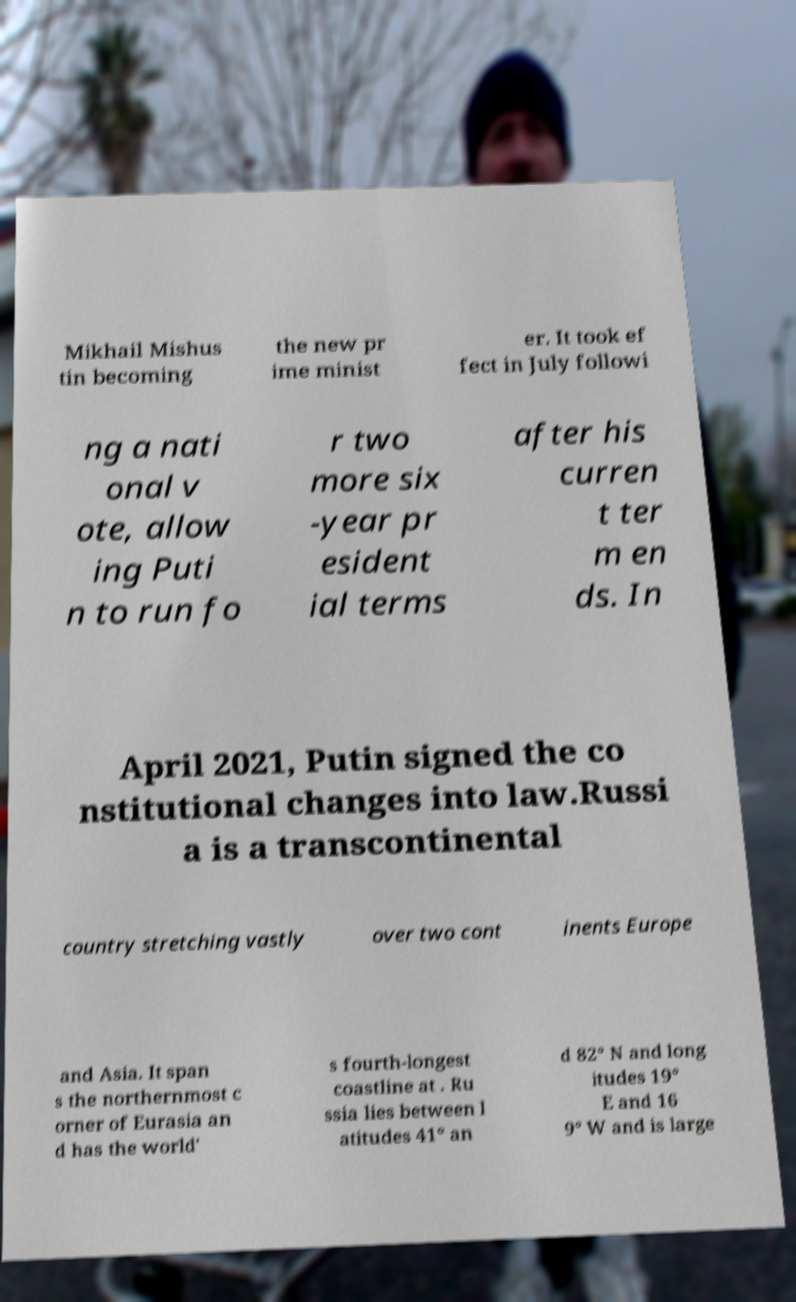Please read and relay the text visible in this image. What does it say? Mikhail Mishus tin becoming the new pr ime minist er. It took ef fect in July followi ng a nati onal v ote, allow ing Puti n to run fo r two more six -year pr esident ial terms after his curren t ter m en ds. In April 2021, Putin signed the co nstitutional changes into law.Russi a is a transcontinental country stretching vastly over two cont inents Europe and Asia. It span s the northernmost c orner of Eurasia an d has the world' s fourth-longest coastline at . Ru ssia lies between l atitudes 41° an d 82° N and long itudes 19° E and 16 9° W and is large 